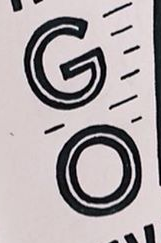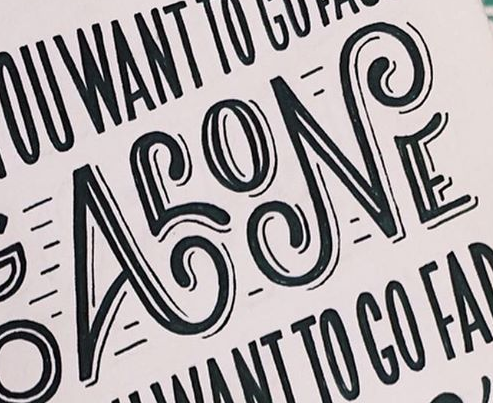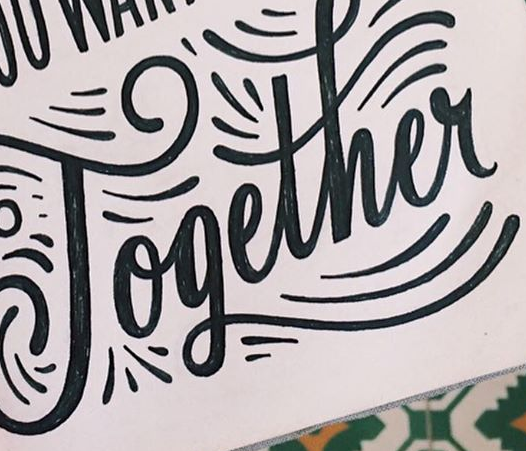Transcribe the words shown in these images in order, separated by a semicolon. GO; ALONE; Together 